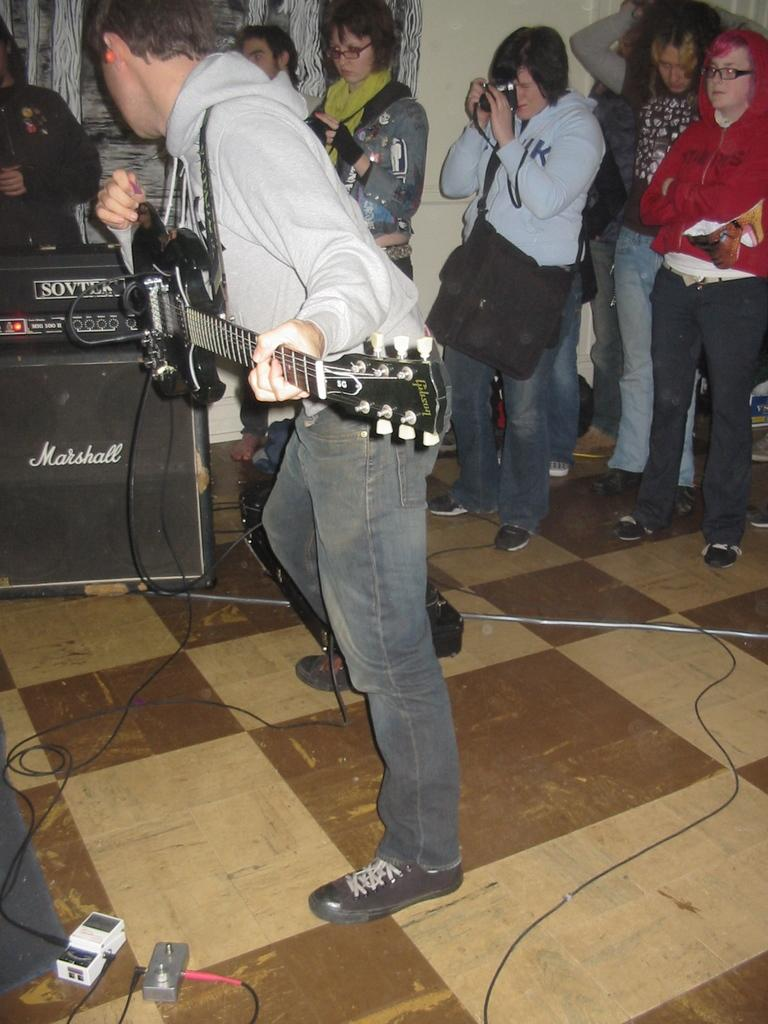What is the person in the image holding? The person is holding a guitar in the image. What can be seen behind the person with the guitar? There is a group of people standing at the back of the person with the guitar. Can you describe one of the people in the group? One person in the group is wearing a bag. What is another person in the group holding? One person in the group is holding a camera. What type of payment is being made by the person holding the guitar in the image? There is no indication of any payment being made in the image; the person is simply holding a guitar. 